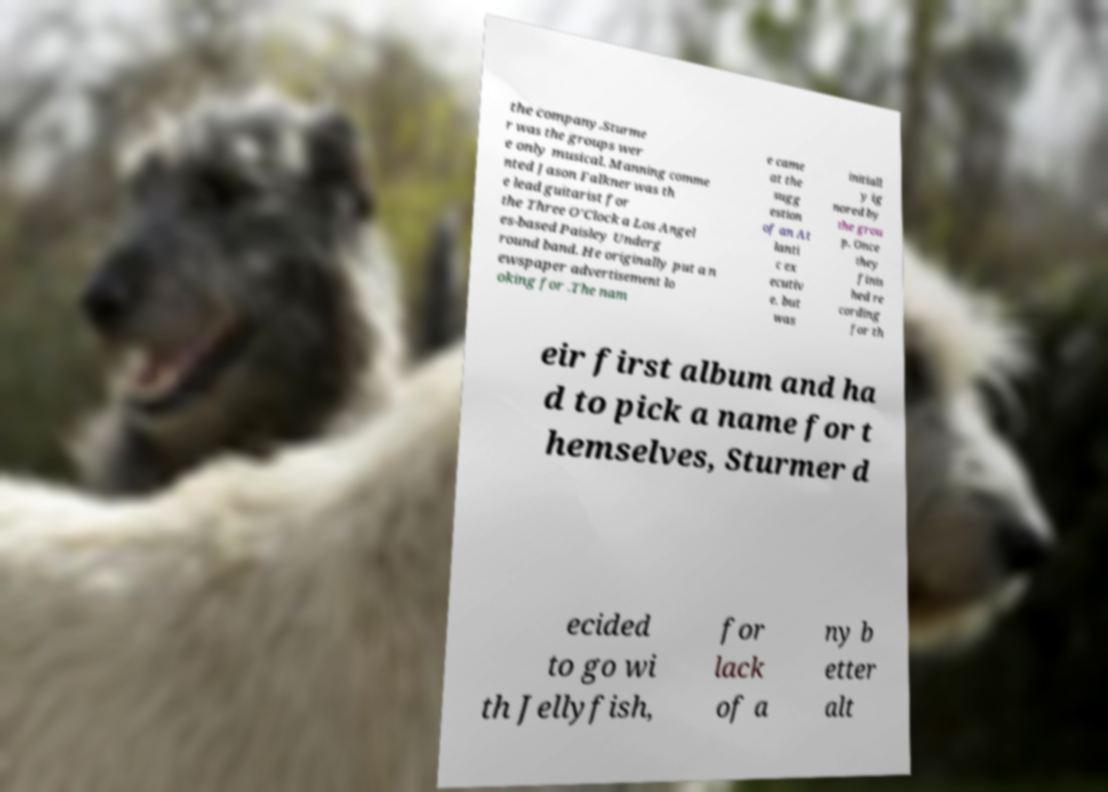For documentation purposes, I need the text within this image transcribed. Could you provide that? the company.Sturme r was the groups wer e only musical. Manning comme nted Jason Falkner was th e lead guitarist for the Three O'Clock a Los Angel es-based Paisley Underg round band. He originally put a n ewspaper advertisement lo oking for .The nam e came at the sugg estion of an At lanti c ex ecutiv e, but was initiall y ig nored by the grou p. Once they finis hed re cording for th eir first album and ha d to pick a name for t hemselves, Sturmer d ecided to go wi th Jellyfish, for lack of a ny b etter alt 